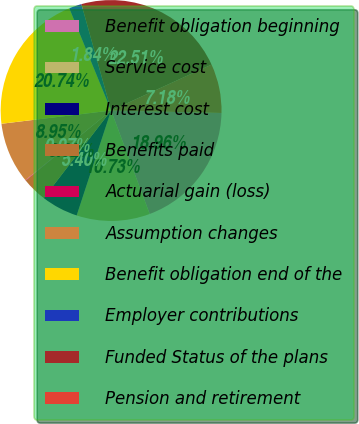<chart> <loc_0><loc_0><loc_500><loc_500><pie_chart><fcel>Benefit obligation beginning<fcel>Service cost<fcel>Interest cost<fcel>Benefits paid<fcel>Actuarial gain (loss)<fcel>Assumption changes<fcel>Benefit obligation end of the<fcel>Employer contributions<fcel>Funded Status of the plans<fcel>Pension and retirement<nl><fcel>18.96%<fcel>10.73%<fcel>5.4%<fcel>3.62%<fcel>0.07%<fcel>8.95%<fcel>20.74%<fcel>1.84%<fcel>22.51%<fcel>7.18%<nl></chart> 